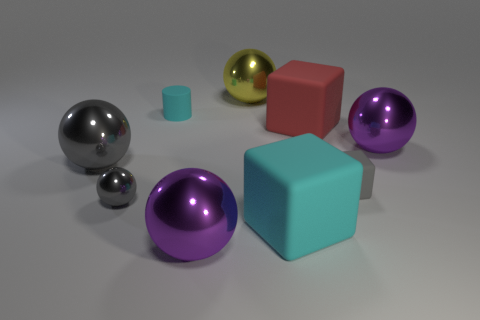Can you explain the lighting in the scene and how it affects the appearance of the objects? The lighting in the scene appears to be soft and diffused, coming from an overhead source. It creates gentle shadows and highlights that enhance the three-dimensionality of the objects, giving a matte finish to the surfaces with less reflection and accentuating the shiny metallic quality of the reflective objects. 